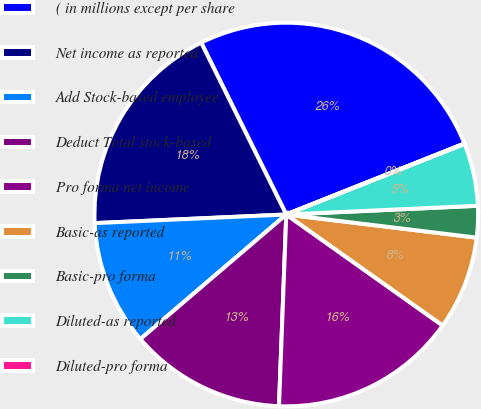<chart> <loc_0><loc_0><loc_500><loc_500><pie_chart><fcel>( in millions except per share<fcel>Net income as reported<fcel>Add Stock-based employee<fcel>Deduct Total stock-based<fcel>Pro forma net income<fcel>Basic-as reported<fcel>Basic-pro forma<fcel>Diluted-as reported<fcel>Diluted-pro forma<nl><fcel>26.28%<fcel>18.4%<fcel>10.53%<fcel>13.15%<fcel>15.78%<fcel>7.9%<fcel>2.65%<fcel>5.28%<fcel>0.03%<nl></chart> 